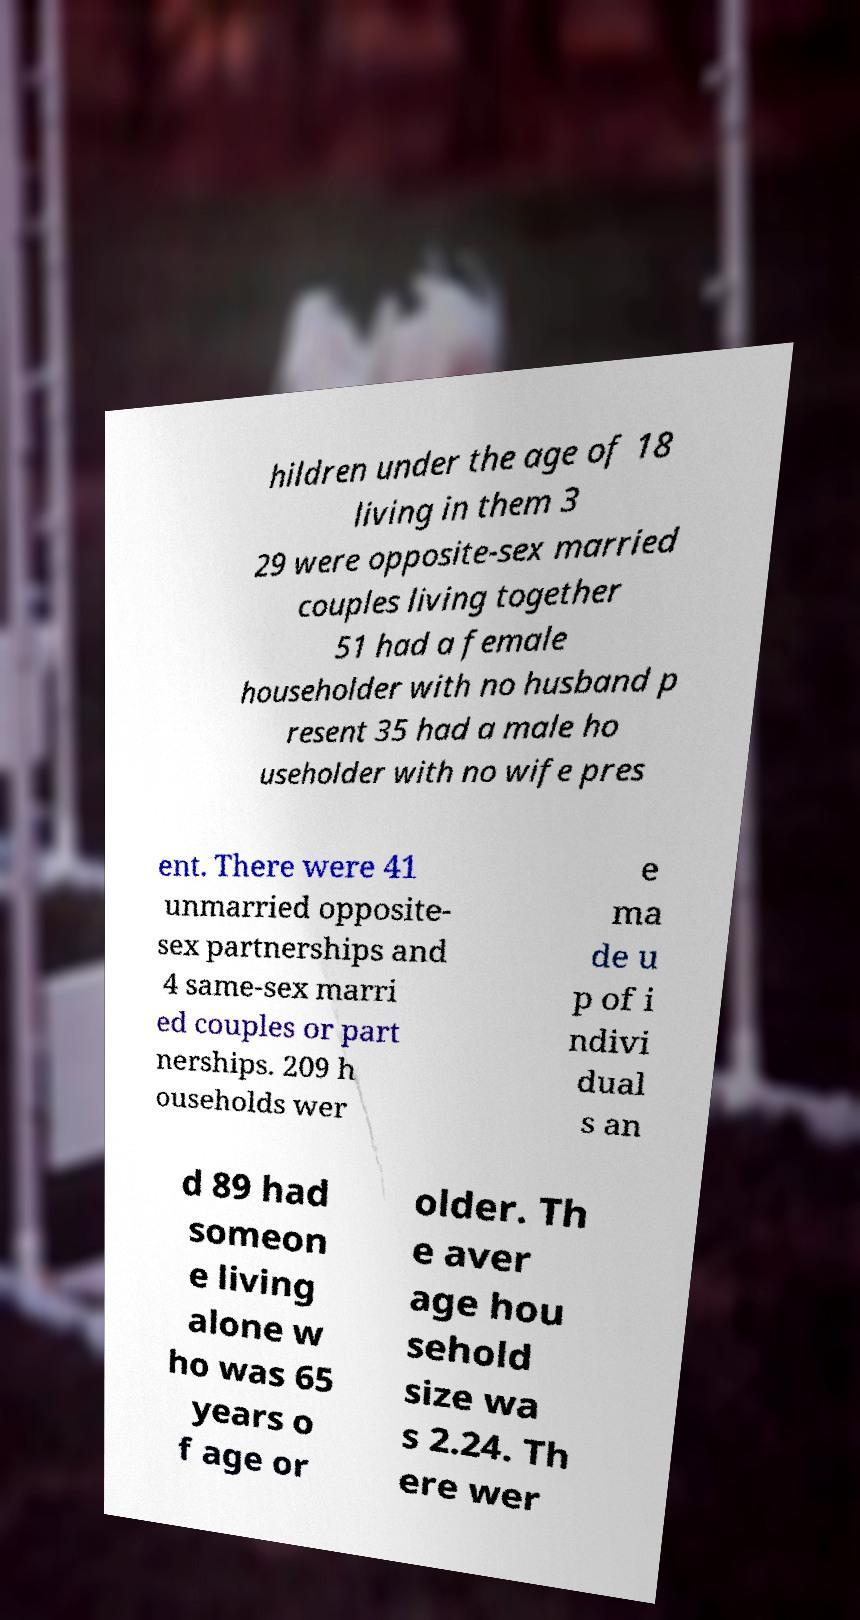Please identify and transcribe the text found in this image. hildren under the age of 18 living in them 3 29 were opposite-sex married couples living together 51 had a female householder with no husband p resent 35 had a male ho useholder with no wife pres ent. There were 41 unmarried opposite- sex partnerships and 4 same-sex marri ed couples or part nerships. 209 h ouseholds wer e ma de u p of i ndivi dual s an d 89 had someon e living alone w ho was 65 years o f age or older. Th e aver age hou sehold size wa s 2.24. Th ere wer 